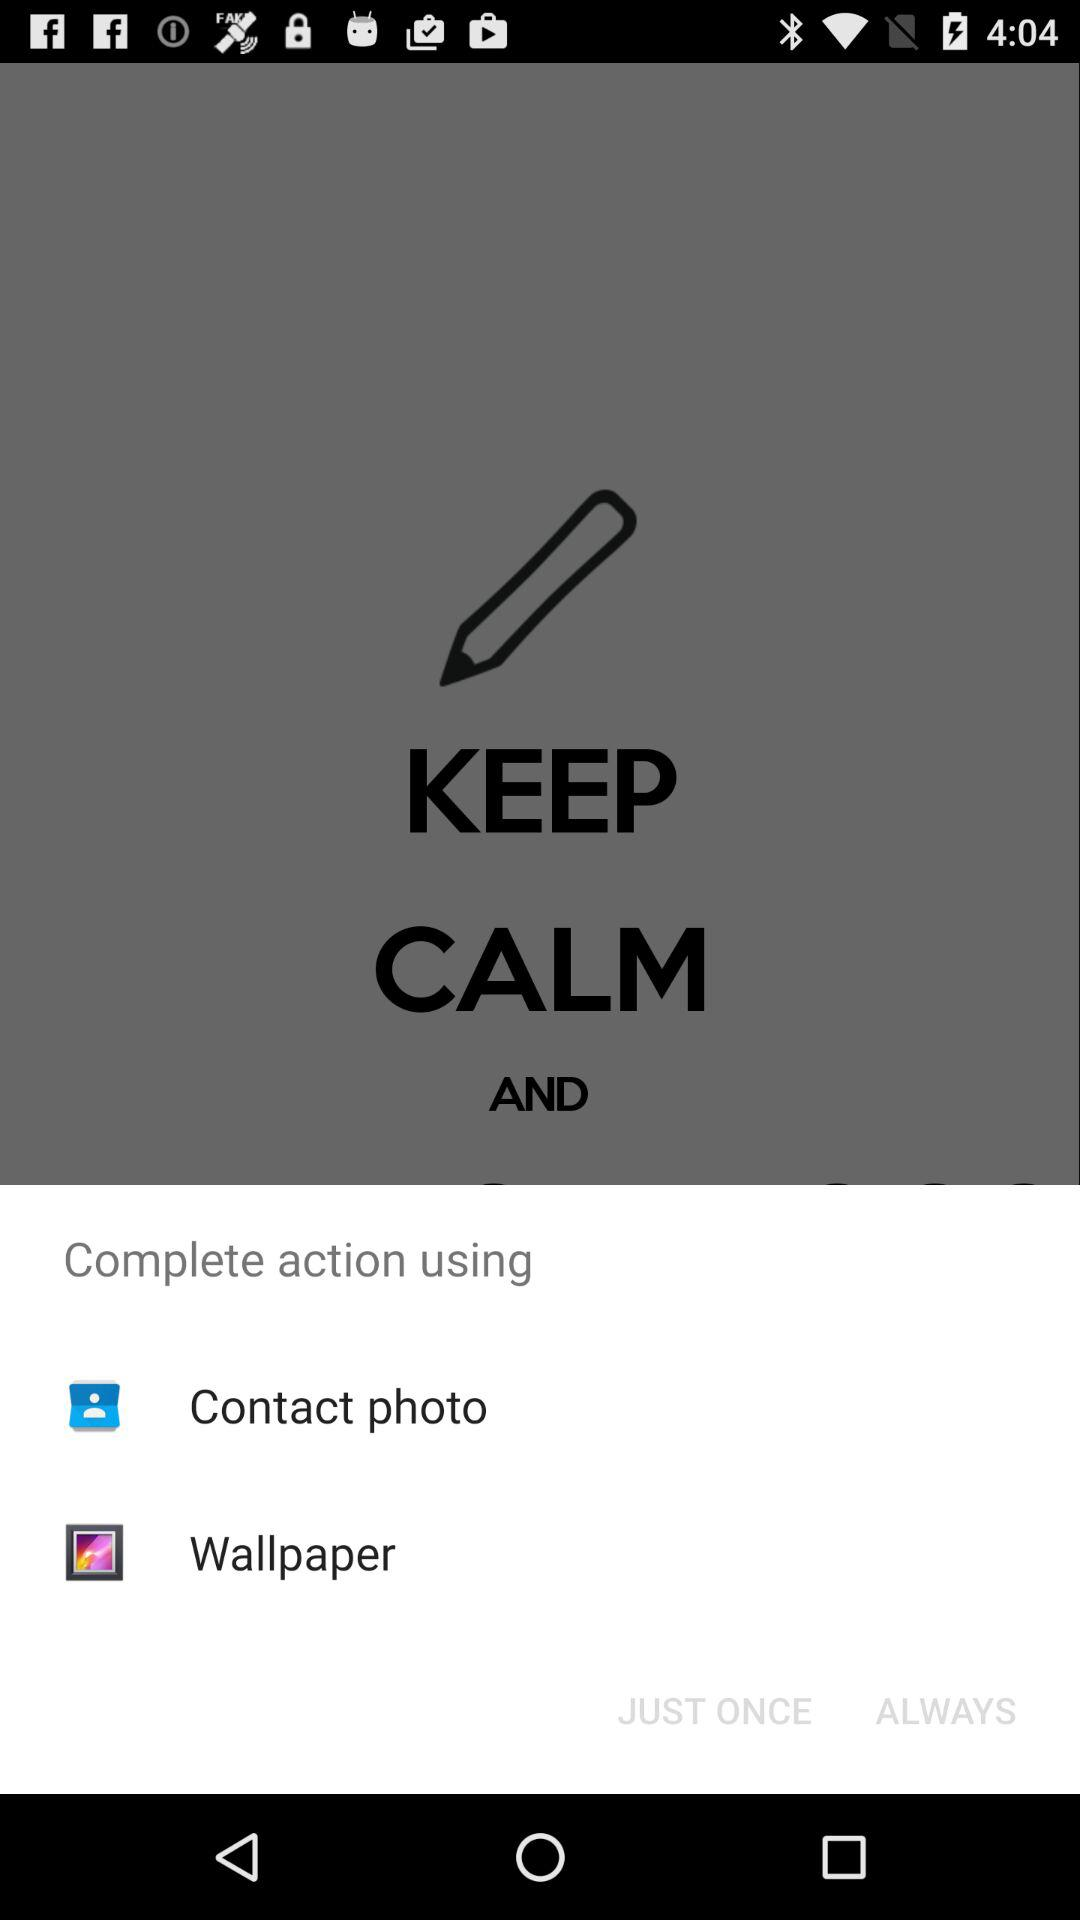What are the different options used to complete the action? The different options used to complete the action are: "Contact photo" and "Wallpaper". 